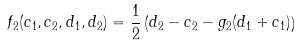<formula> <loc_0><loc_0><loc_500><loc_500>f _ { 2 } ( c _ { 1 } , c _ { 2 } , d _ { 1 } , d _ { 2 } ) = \frac { 1 } { 2 } \left ( d _ { 2 } - c _ { 2 } - g _ { 2 } ( d _ { 1 } + c _ { 1 } ) \right )</formula> 